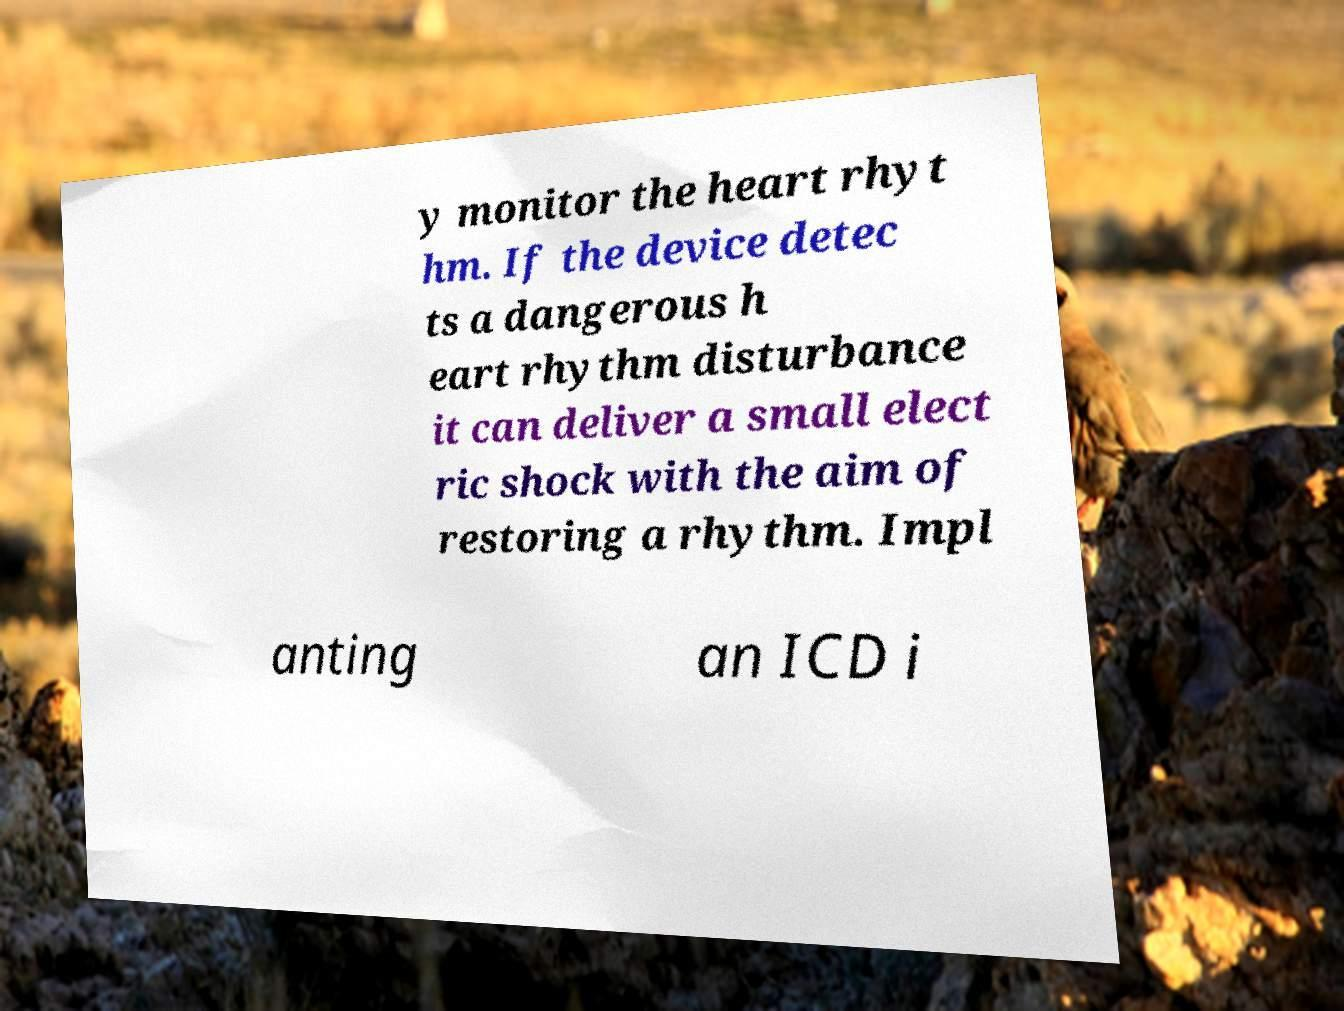Can you accurately transcribe the text from the provided image for me? y monitor the heart rhyt hm. If the device detec ts a dangerous h eart rhythm disturbance it can deliver a small elect ric shock with the aim of restoring a rhythm. Impl anting an ICD i 